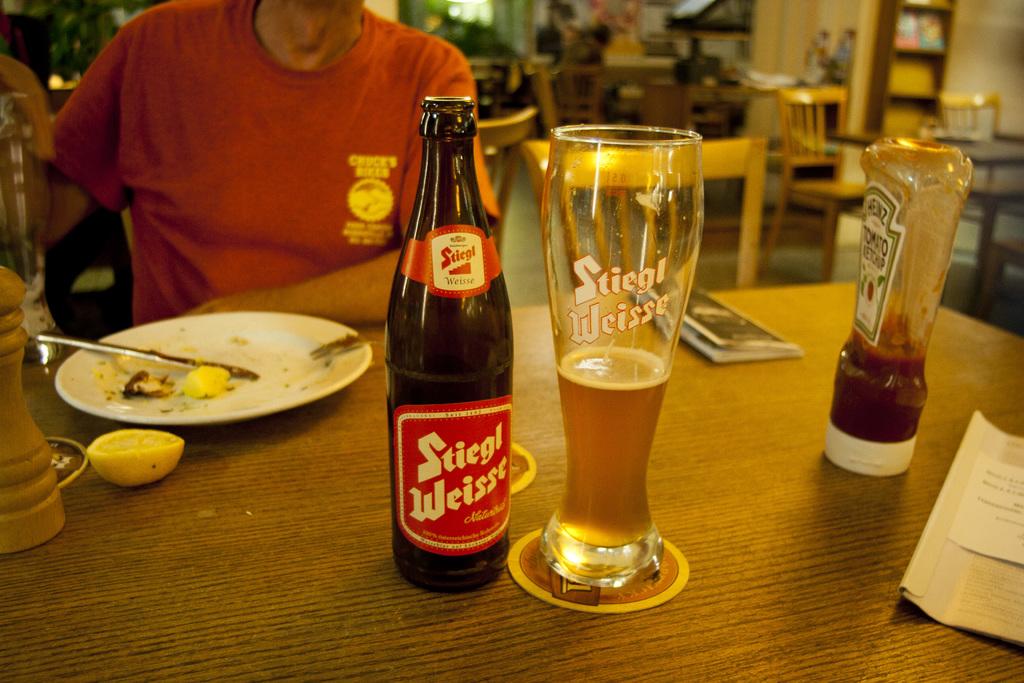What is this beer name, both on the bottle and the glass?
Provide a short and direct response. Stiegl weisse. What kind of ketchup?
Your response must be concise. Heinz. 